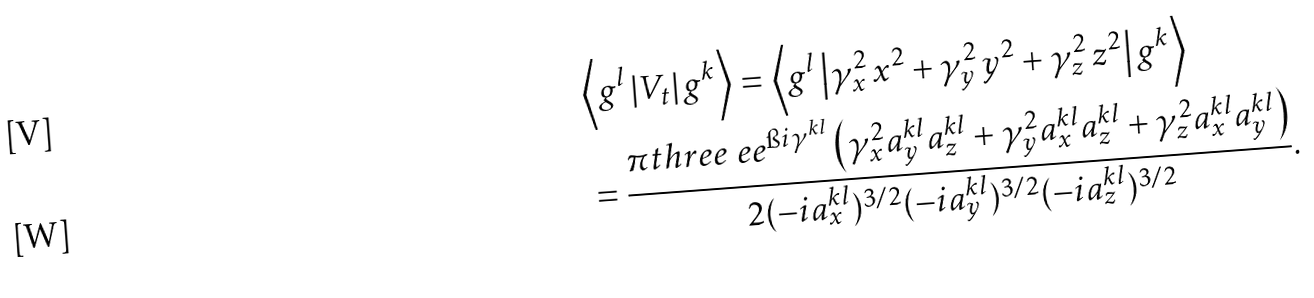<formula> <loc_0><loc_0><loc_500><loc_500>& \Big < g ^ { l } \left | V _ { t } \right | g ^ { k } \Big > = \Big < g ^ { l } \left | \gamma _ { x } ^ { 2 } \, x ^ { 2 } + \gamma _ { y } ^ { 2 } \, y ^ { 2 } + \gamma _ { z } ^ { 2 } \, z ^ { 2 } \right | g ^ { k } \Big > \\ & = \frac { \pi t h r e e \ e e ^ { \i i \gamma ^ { k l } } \left ( \gamma _ { x } ^ { 2 } a _ { y } ^ { k l } a _ { z } ^ { k l } + \gamma _ { y } ^ { 2 } a _ { x } ^ { k l } a _ { z } ^ { k l } + \gamma _ { z } ^ { 2 } a _ { x } ^ { k l } a _ { y } ^ { k l } \right ) } { 2 ( - i a _ { x } ^ { k l } ) ^ { 3 / 2 } ( - i a _ { y } ^ { k l } ) ^ { 3 / 2 } ( - i a _ { z } ^ { k l } ) ^ { 3 / 2 } } .</formula> 